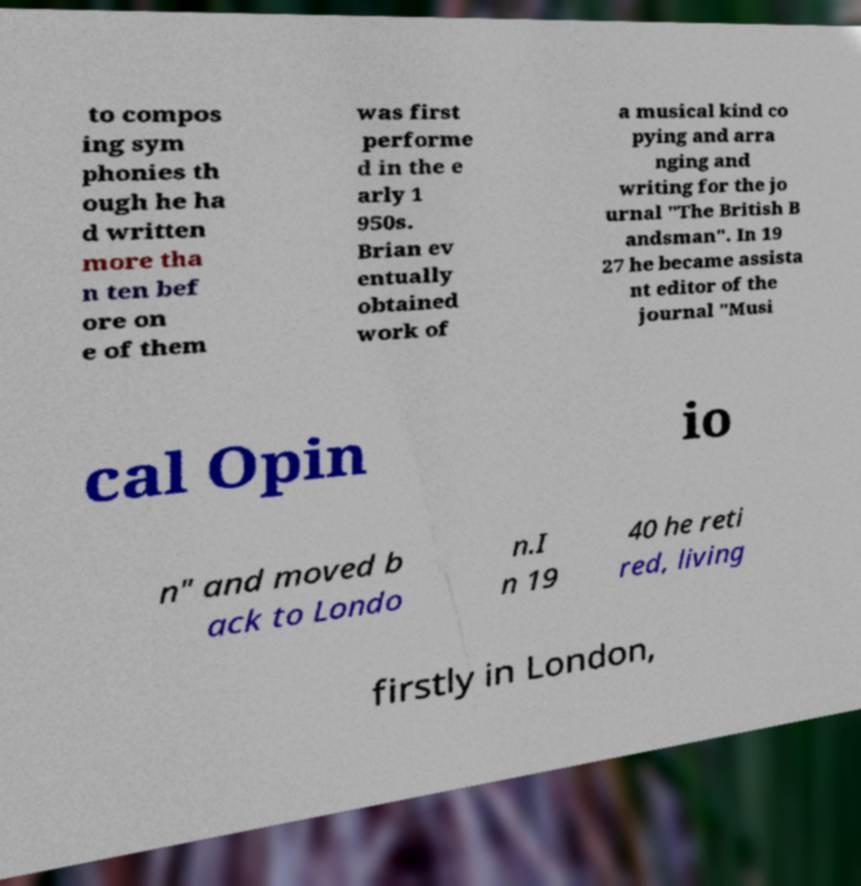Could you assist in decoding the text presented in this image and type it out clearly? to compos ing sym phonies th ough he ha d written more tha n ten bef ore on e of them was first performe d in the e arly 1 950s. Brian ev entually obtained work of a musical kind co pying and arra nging and writing for the jo urnal "The British B andsman". In 19 27 he became assista nt editor of the journal "Musi cal Opin io n" and moved b ack to Londo n.I n 19 40 he reti red, living firstly in London, 